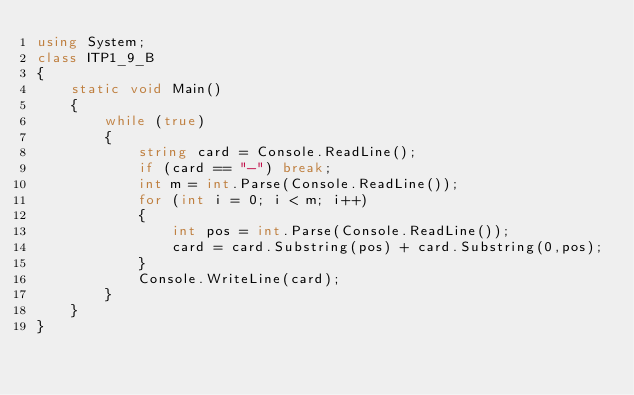<code> <loc_0><loc_0><loc_500><loc_500><_C#_>using System;
class ITP1_9_B
{
    static void Main()
    {
        while (true)
        {
            string card = Console.ReadLine();
            if (card == "-") break;
            int m = int.Parse(Console.ReadLine());
            for (int i = 0; i < m; i++)
            {
                int pos = int.Parse(Console.ReadLine());
                card = card.Substring(pos) + card.Substring(0,pos);
            }
            Console.WriteLine(card);
        }
    }
}</code> 